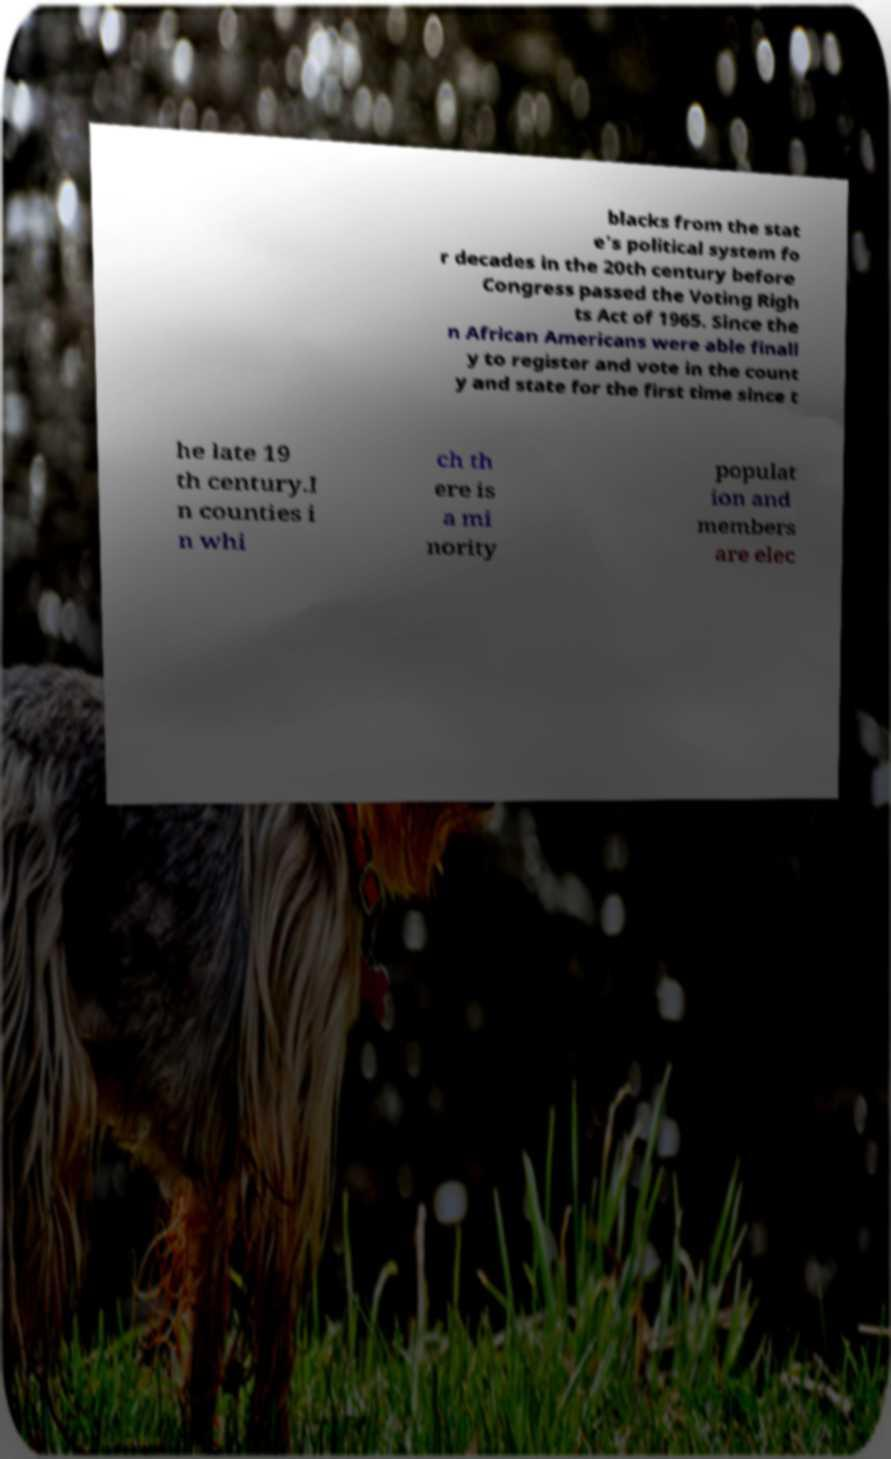Could you extract and type out the text from this image? blacks from the stat e's political system fo r decades in the 20th century before Congress passed the Voting Righ ts Act of 1965. Since the n African Americans were able finall y to register and vote in the count y and state for the first time since t he late 19 th century.I n counties i n whi ch th ere is a mi nority populat ion and members are elec 